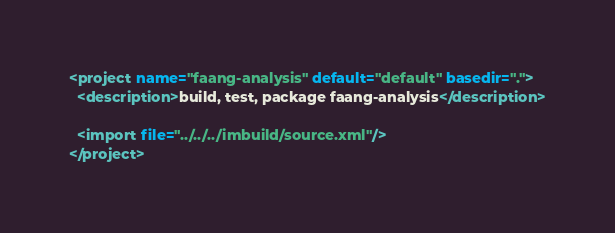Convert code to text. <code><loc_0><loc_0><loc_500><loc_500><_XML_><project name="faang-analysis" default="default" basedir=".">
  <description>build, test, package faang-analysis</description>
  
  <import file="../../../imbuild/source.xml"/>
</project>
</code> 